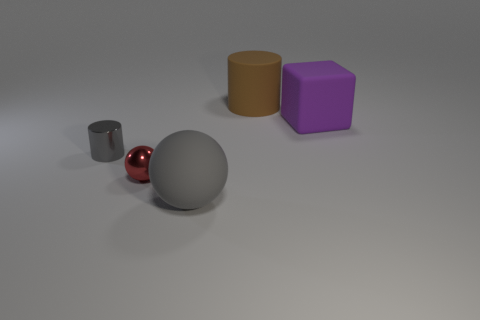Add 4 tiny metal cylinders. How many objects exist? 9 Subtract all brown balls. Subtract all gray cylinders. How many balls are left? 2 Subtract all cubes. How many objects are left? 4 Add 3 small gray metallic cylinders. How many small gray metallic cylinders are left? 4 Add 3 brown cylinders. How many brown cylinders exist? 4 Subtract 0 blue blocks. How many objects are left? 5 Subtract all gray metal cylinders. Subtract all gray matte objects. How many objects are left? 3 